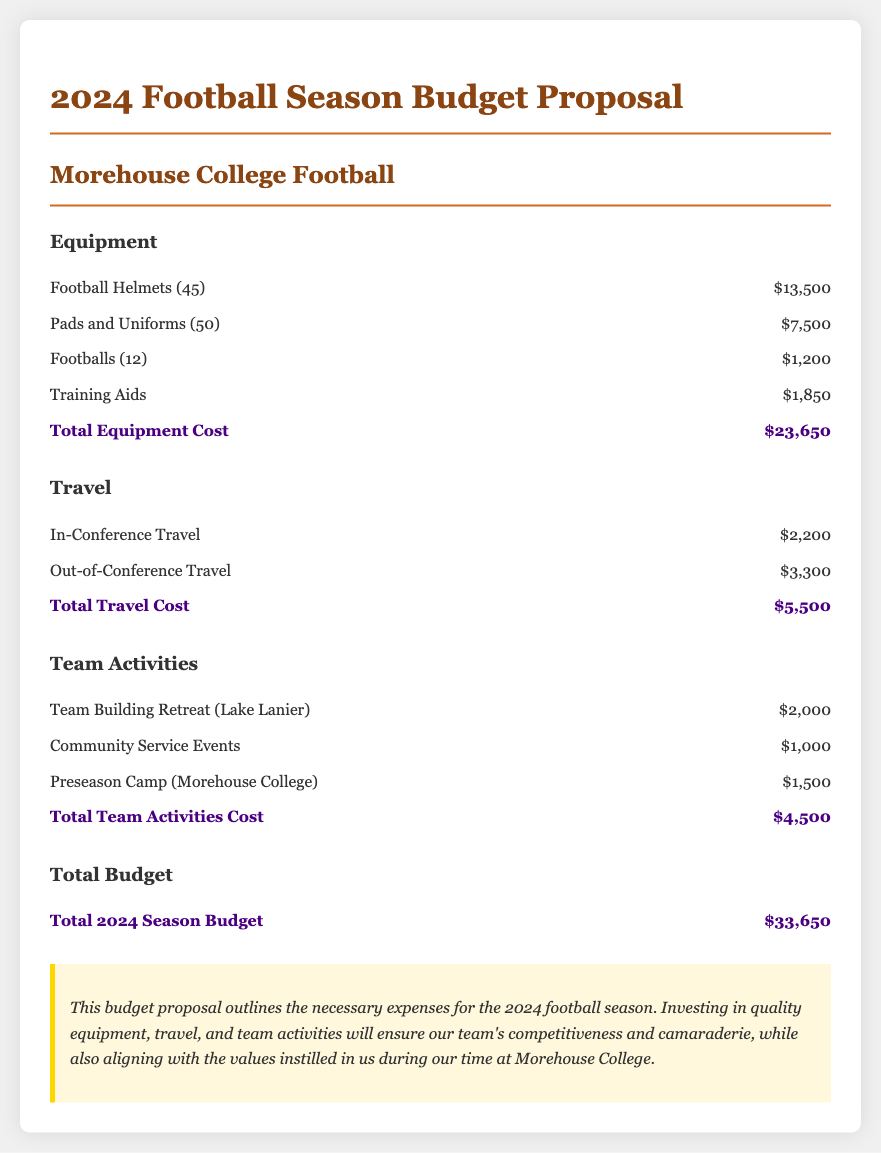What is the total cost for equipment? The total cost for equipment is provided in the budget proposal which sums up all equipment expenses listed.
Answer: $23,650 How much is allocated for out-of-conference travel? The document specifies the cost for out-of-conference travel in the travel section, detailing expenses incurred for travel outside the conference.
Answer: $3,300 What is the total amount budgeted for team activities? The total amount for team activities is calculated by adding together all expenses related to team activities listed in the document.
Answer: $4,500 How many football helmets are included in the equipment budget? The number of football helmets is explicitly mentioned in the equipment section of the proposal.
Answer: 45 What is the total budget for the 2024 season? The total budget is calculated by summing up all the costs from equipment, travel, and team activities as outlined in the document.
Answer: $33,650 What is the purpose of the budget proposal? The budget proposal outlines the financial needs necessary for specific aspects of the football season and highlights its importance for team performance and bonding.
Answer: To ensure competitiveness and camaraderie 